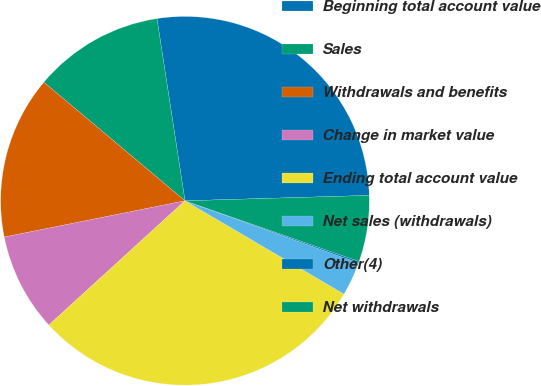Convert chart. <chart><loc_0><loc_0><loc_500><loc_500><pie_chart><fcel>Beginning total account value<fcel>Sales<fcel>Withdrawals and benefits<fcel>Change in market value<fcel>Ending total account value<fcel>Net sales (withdrawals)<fcel>Other(4)<fcel>Net withdrawals<nl><fcel>26.96%<fcel>11.45%<fcel>14.27%<fcel>8.62%<fcel>29.78%<fcel>2.97%<fcel>0.14%<fcel>5.8%<nl></chart> 